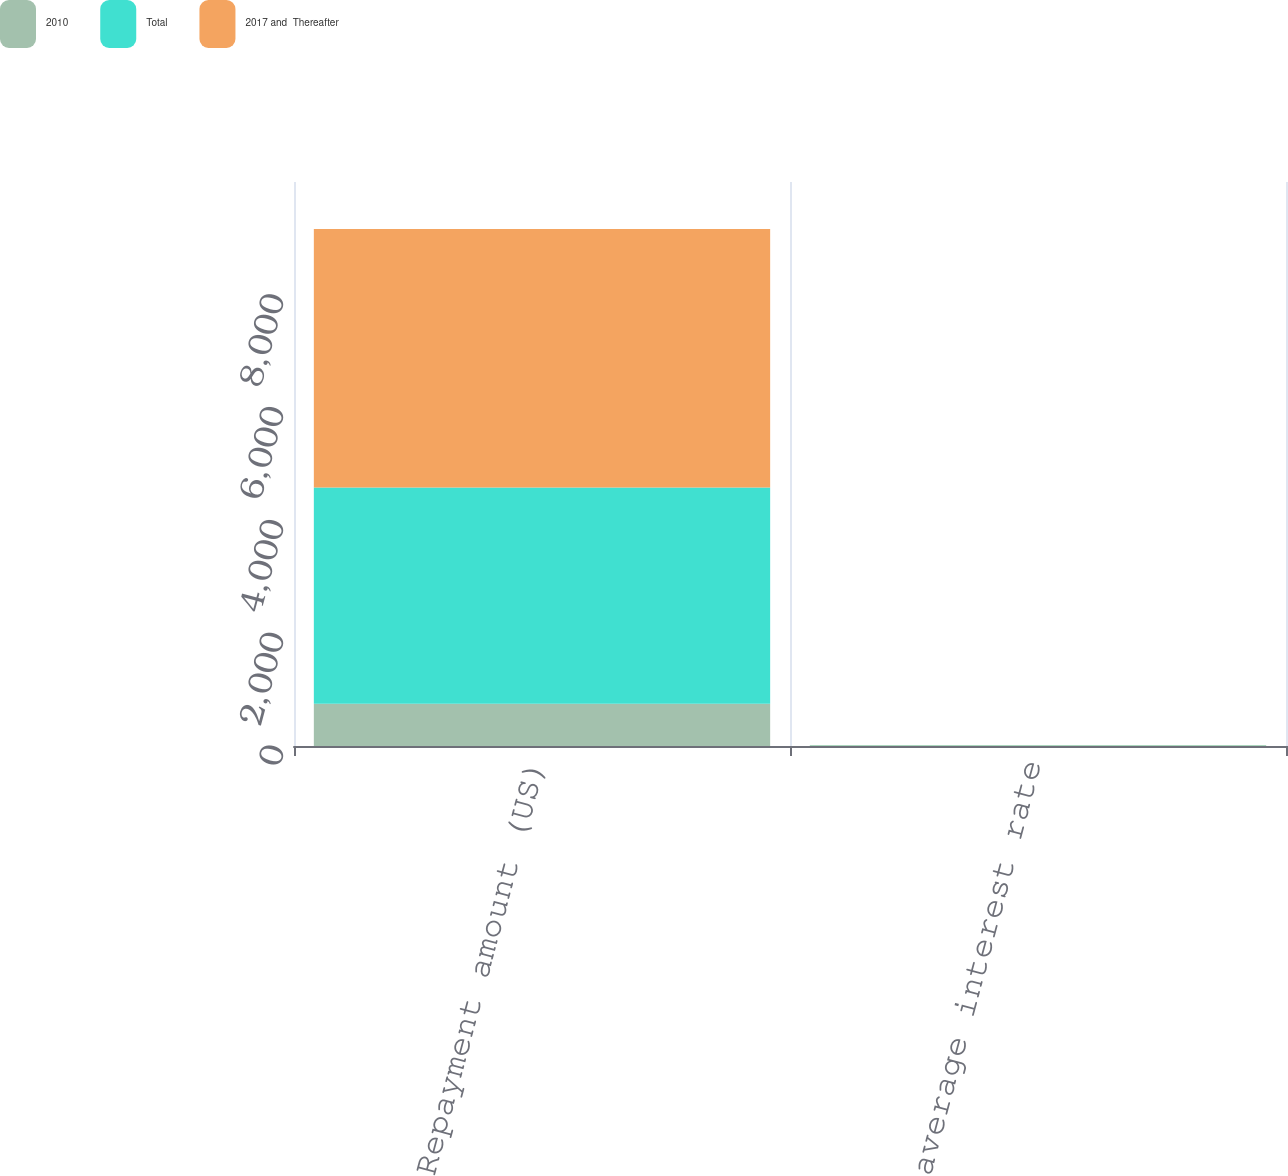Convert chart to OTSL. <chart><loc_0><loc_0><loc_500><loc_500><stacked_bar_chart><ecel><fcel>Repayment amount (US)<fcel>Weighted average interest rate<nl><fcel>2010<fcel>750<fcel>5.5<nl><fcel>Total<fcel>3834<fcel>6.9<nl><fcel>2017 and  Thereafter<fcel>4584<fcel>6.6<nl></chart> 